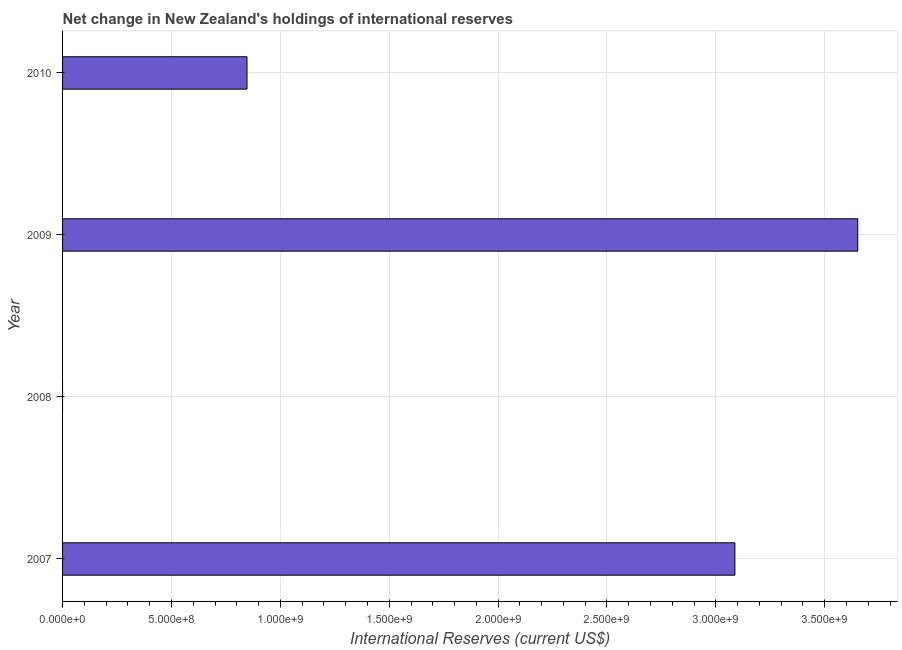Does the graph contain any zero values?
Give a very brief answer. Yes. Does the graph contain grids?
Your answer should be very brief. Yes. What is the title of the graph?
Keep it short and to the point. Net change in New Zealand's holdings of international reserves. What is the label or title of the X-axis?
Offer a terse response. International Reserves (current US$). What is the label or title of the Y-axis?
Offer a very short reply. Year. What is the reserves and related items in 2007?
Provide a succinct answer. 3.09e+09. Across all years, what is the maximum reserves and related items?
Your response must be concise. 3.65e+09. Across all years, what is the minimum reserves and related items?
Ensure brevity in your answer.  0. In which year was the reserves and related items maximum?
Offer a very short reply. 2009. What is the sum of the reserves and related items?
Make the answer very short. 7.59e+09. What is the difference between the reserves and related items in 2009 and 2010?
Offer a very short reply. 2.80e+09. What is the average reserves and related items per year?
Offer a terse response. 1.90e+09. What is the median reserves and related items?
Give a very brief answer. 1.97e+09. In how many years, is the reserves and related items greater than 1300000000 US$?
Provide a short and direct response. 2. What is the ratio of the reserves and related items in 2007 to that in 2010?
Keep it short and to the point. 3.65. Is the reserves and related items in 2007 less than that in 2010?
Offer a terse response. No. What is the difference between the highest and the second highest reserves and related items?
Make the answer very short. 5.64e+08. What is the difference between the highest and the lowest reserves and related items?
Give a very brief answer. 3.65e+09. In how many years, is the reserves and related items greater than the average reserves and related items taken over all years?
Make the answer very short. 2. Are all the bars in the graph horizontal?
Give a very brief answer. Yes. How many years are there in the graph?
Offer a very short reply. 4. Are the values on the major ticks of X-axis written in scientific E-notation?
Ensure brevity in your answer.  Yes. What is the International Reserves (current US$) of 2007?
Offer a terse response. 3.09e+09. What is the International Reserves (current US$) of 2009?
Your response must be concise. 3.65e+09. What is the International Reserves (current US$) of 2010?
Offer a very short reply. 8.47e+08. What is the difference between the International Reserves (current US$) in 2007 and 2009?
Offer a terse response. -5.64e+08. What is the difference between the International Reserves (current US$) in 2007 and 2010?
Offer a very short reply. 2.24e+09. What is the difference between the International Reserves (current US$) in 2009 and 2010?
Provide a succinct answer. 2.80e+09. What is the ratio of the International Reserves (current US$) in 2007 to that in 2009?
Offer a very short reply. 0.85. What is the ratio of the International Reserves (current US$) in 2007 to that in 2010?
Offer a very short reply. 3.65. What is the ratio of the International Reserves (current US$) in 2009 to that in 2010?
Give a very brief answer. 4.31. 